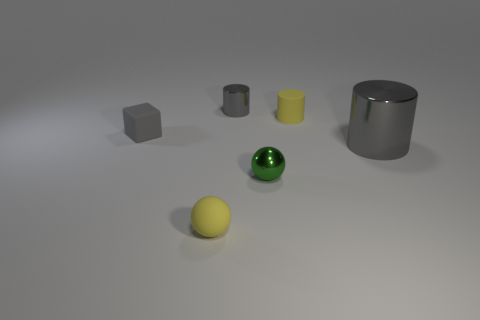Is the number of matte cylinders that are in front of the green metallic ball greater than the number of gray objects to the right of the matte sphere?
Your answer should be compact. No. There is a object that is to the right of the yellow object that is behind the gray metal cylinder right of the small green metallic object; what is its material?
Offer a very short reply. Metal. Is the shape of the small shiny object in front of the small gray matte thing the same as the yellow object in front of the tiny yellow cylinder?
Provide a succinct answer. Yes. Is there another blue metallic block that has the same size as the cube?
Ensure brevity in your answer.  No. How many yellow objects are tiny matte cubes or tiny metallic cylinders?
Your answer should be very brief. 0. How many big metal cylinders have the same color as the small rubber block?
Provide a short and direct response. 1. Is there any other thing that is the same shape as the small green shiny object?
Offer a very short reply. Yes. How many spheres are either yellow matte objects or shiny objects?
Your answer should be very brief. 2. What color is the metallic cylinder that is in front of the yellow cylinder?
Offer a very short reply. Gray. There is a yellow object that is the same size as the matte cylinder; what is its shape?
Provide a succinct answer. Sphere. 